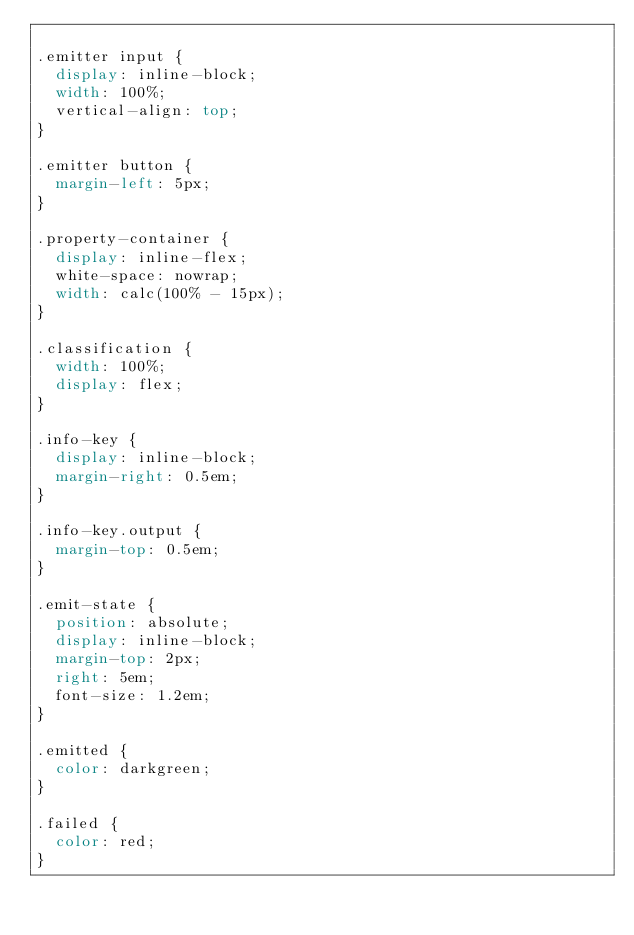<code> <loc_0><loc_0><loc_500><loc_500><_CSS_>
.emitter input {
  display: inline-block;
  width: 100%;
  vertical-align: top;
}

.emitter button {
  margin-left: 5px;
}

.property-container {
  display: inline-flex;
  white-space: nowrap;
  width: calc(100% - 15px);
}

.classification {
  width: 100%;
  display: flex;
}

.info-key {
  display: inline-block;
  margin-right: 0.5em;
}

.info-key.output {
  margin-top: 0.5em;
}

.emit-state {
  position: absolute;
  display: inline-block;
  margin-top: 2px;
  right: 5em;
  font-size: 1.2em;
}

.emitted {
  color: darkgreen;
}

.failed {
  color: red;
}</code> 